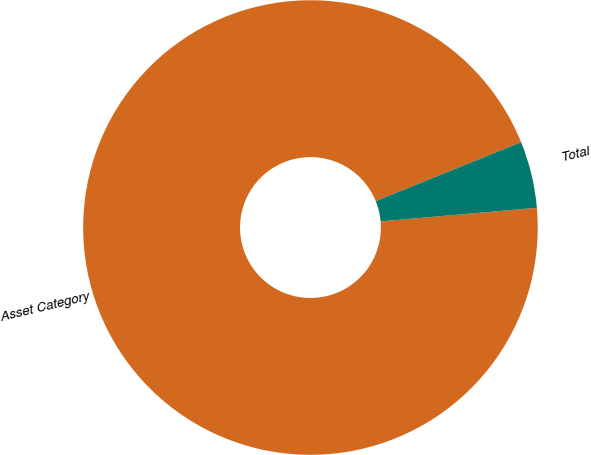<chart> <loc_0><loc_0><loc_500><loc_500><pie_chart><fcel>Asset Category<fcel>Total<nl><fcel>95.26%<fcel>4.74%<nl></chart> 